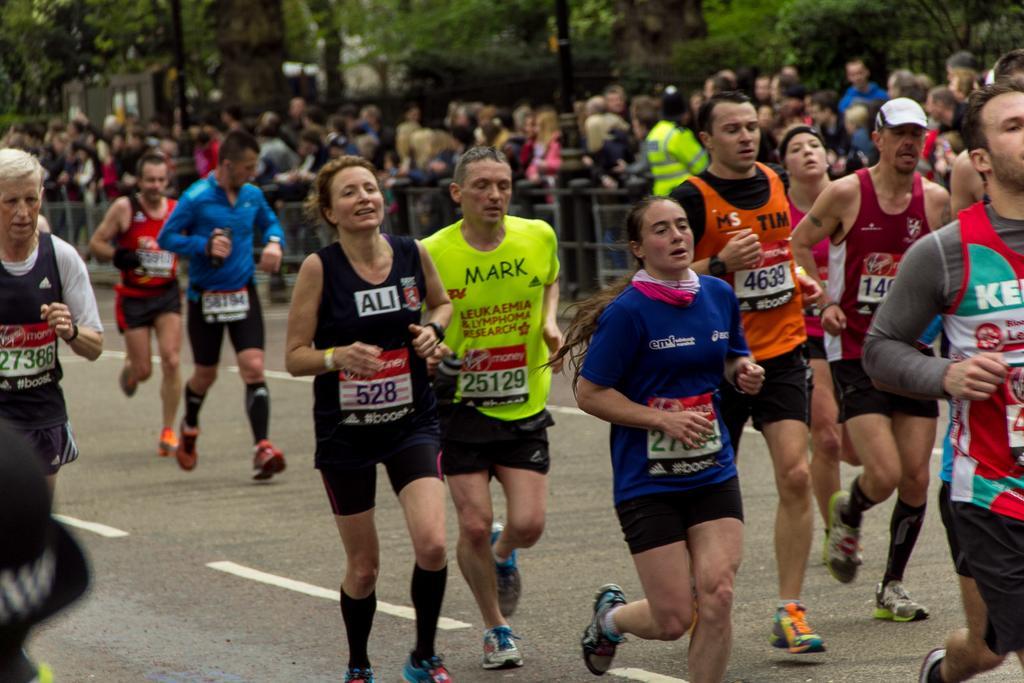Describe this image in one or two sentences. In this image we can see the people running. We can also see the barrier and behind the barrier we can see many people standing. We can also see the trees and also the road. 